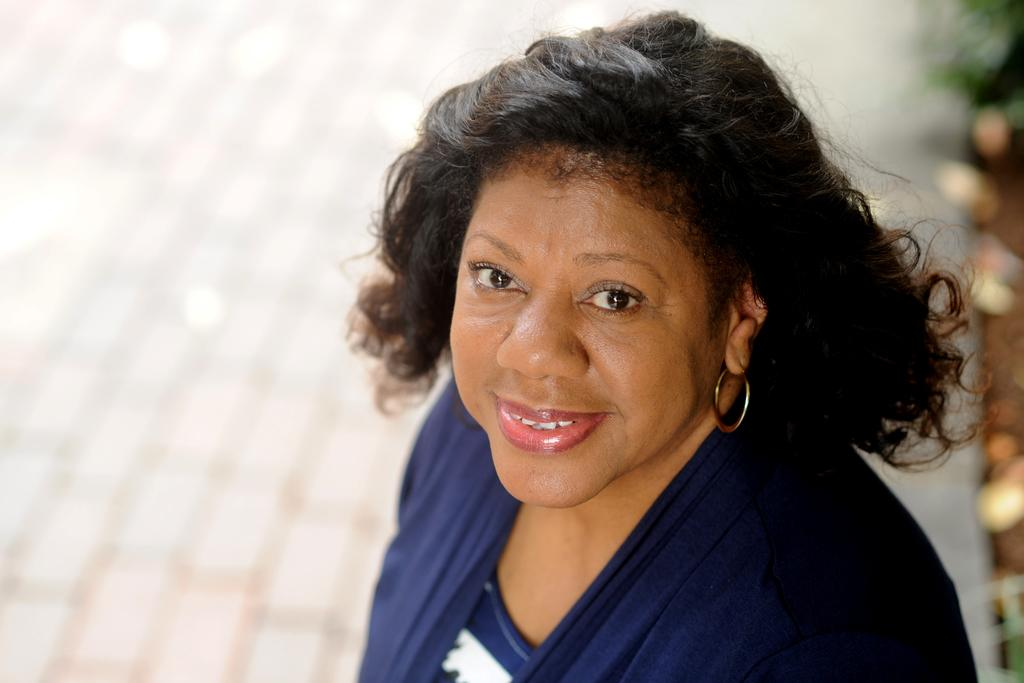Who or what is present in the image? There is a person in the image. What is the person wearing? The person is wearing a blue dress. What color is the background of the image? The background of the image is white. What type of wax can be seen melting in the image? There is no wax present in the image, so it cannot be determined if any wax is melting. 